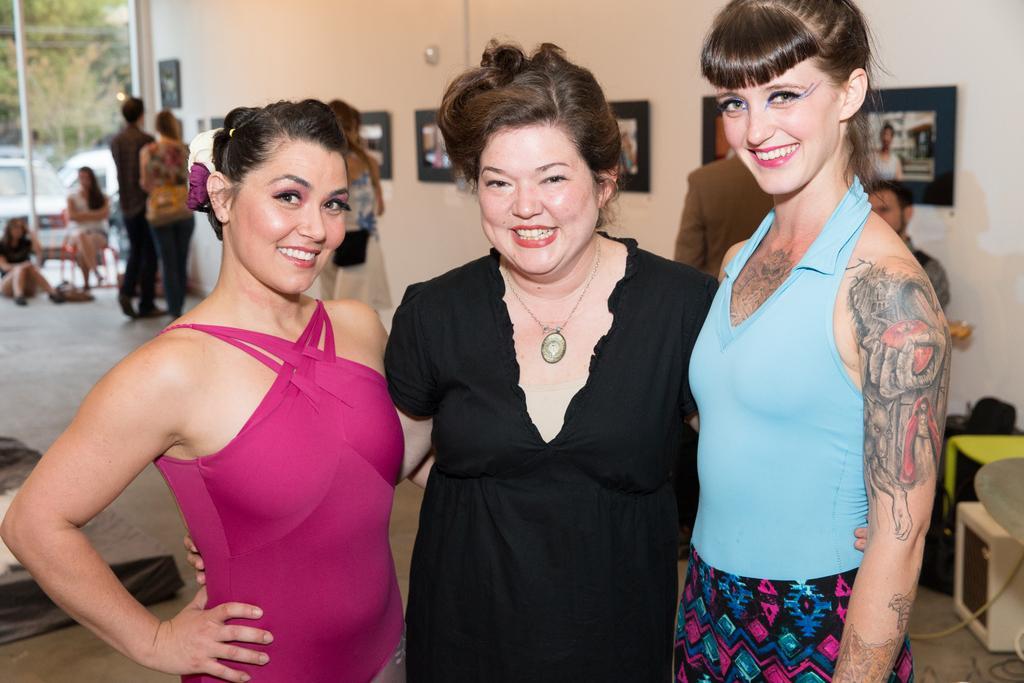Can you describe this image briefly? In this image there are three ladies standing on the floor in the middle. In the background there is a wall to which there are photo frames. In the background there are people standing on the floor near the wall and looking at the frames. On the left side top corner there is a glass through which we can see the vehicles. 